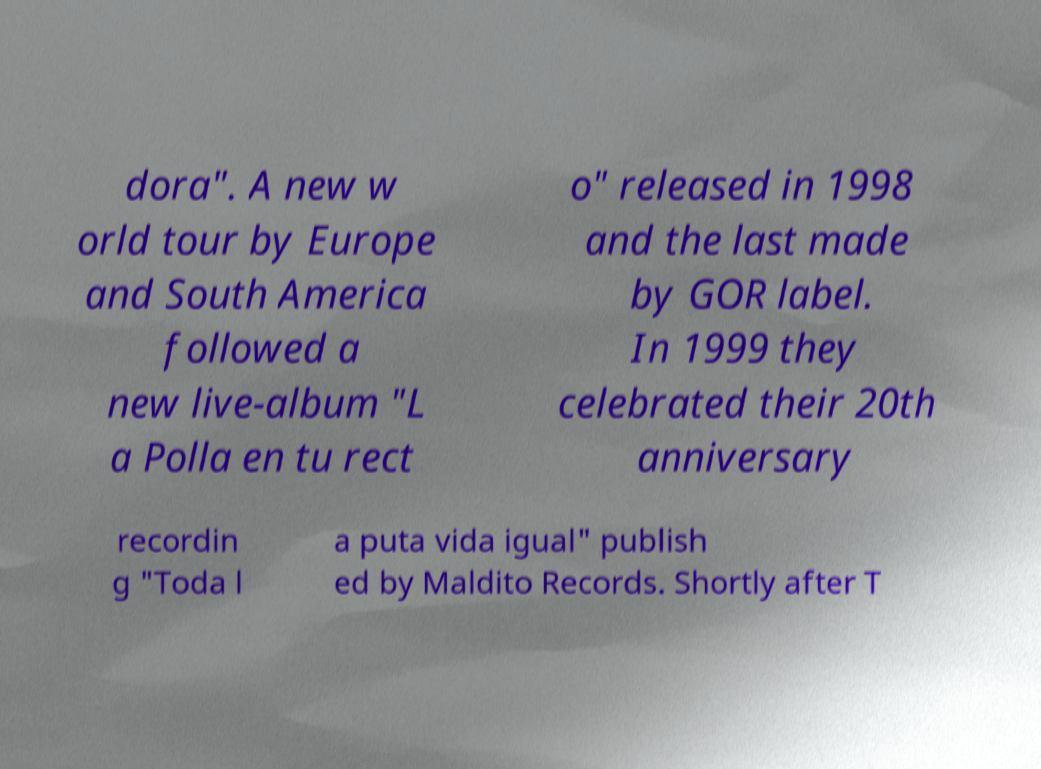Could you assist in decoding the text presented in this image and type it out clearly? dora". A new w orld tour by Europe and South America followed a new live-album "L a Polla en tu rect o" released in 1998 and the last made by GOR label. In 1999 they celebrated their 20th anniversary recordin g "Toda l a puta vida igual" publish ed by Maldito Records. Shortly after T 